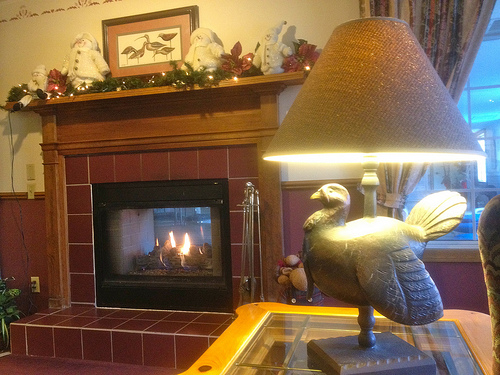<image>
Can you confirm if the wall is behind the light? Yes. From this viewpoint, the wall is positioned behind the light, with the light partially or fully occluding the wall. 